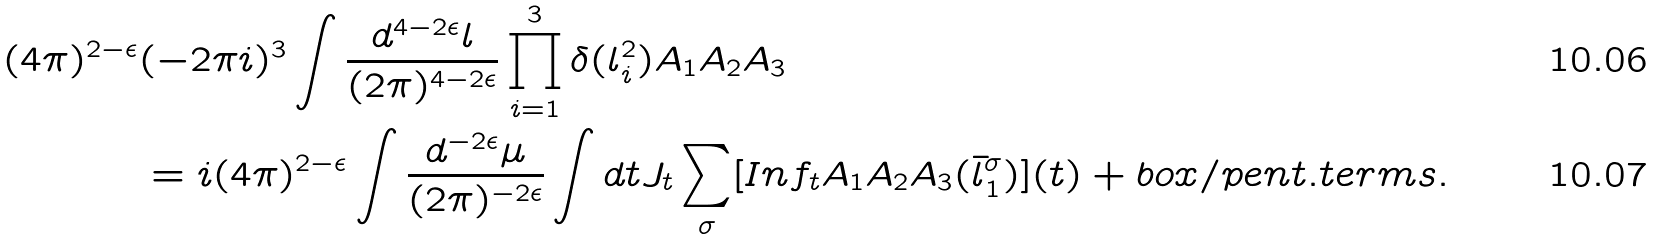<formula> <loc_0><loc_0><loc_500><loc_500>( 4 \pi ) ^ { 2 - \epsilon } & ( - 2 \pi i ) ^ { 3 } \int \frac { d ^ { 4 - 2 \epsilon } l } { ( 2 \pi ) ^ { 4 - 2 \epsilon } } \prod _ { i = 1 } ^ { 3 } \delta ( l _ { i } ^ { 2 } ) A _ { 1 } A _ { 2 } A _ { 3 } \\ & = i ( 4 \pi ) ^ { 2 - \epsilon } \int \frac { d ^ { - 2 \epsilon } \mu } { ( 2 \pi ) ^ { - 2 \epsilon } } \int d t J _ { t } \sum _ { \sigma } [ I n f _ { t } A _ { 1 } A _ { 2 } A _ { 3 } ( \bar { l } _ { 1 } ^ { \sigma } ) ] ( t ) + b o x / p e n t . t e r m s .</formula> 